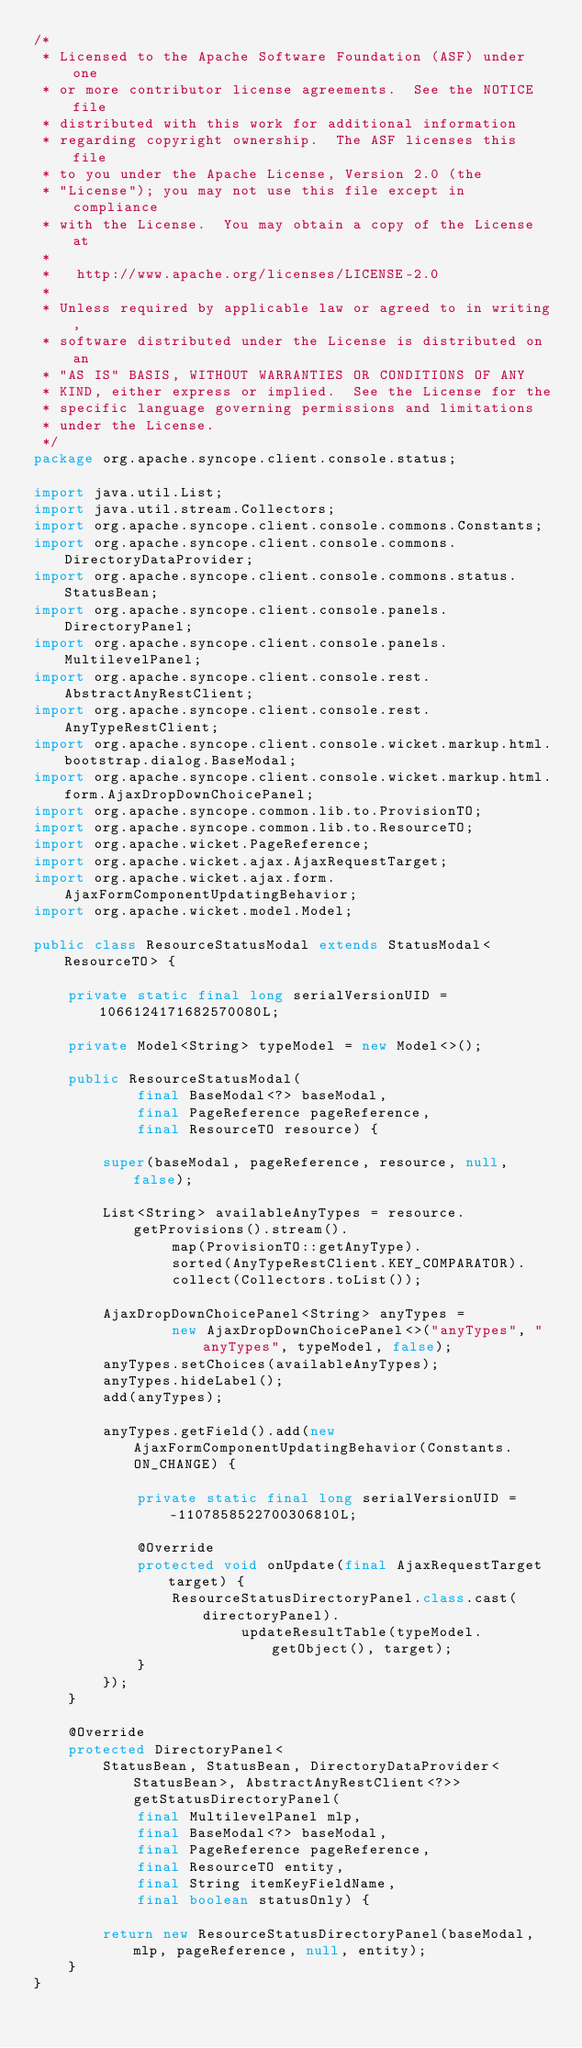<code> <loc_0><loc_0><loc_500><loc_500><_Java_>/*
 * Licensed to the Apache Software Foundation (ASF) under one
 * or more contributor license agreements.  See the NOTICE file
 * distributed with this work for additional information
 * regarding copyright ownership.  The ASF licenses this file
 * to you under the Apache License, Version 2.0 (the
 * "License"); you may not use this file except in compliance
 * with the License.  You may obtain a copy of the License at
 *
 *   http://www.apache.org/licenses/LICENSE-2.0
 *
 * Unless required by applicable law or agreed to in writing,
 * software distributed under the License is distributed on an
 * "AS IS" BASIS, WITHOUT WARRANTIES OR CONDITIONS OF ANY
 * KIND, either express or implied.  See the License for the
 * specific language governing permissions and limitations
 * under the License.
 */
package org.apache.syncope.client.console.status;

import java.util.List;
import java.util.stream.Collectors;
import org.apache.syncope.client.console.commons.Constants;
import org.apache.syncope.client.console.commons.DirectoryDataProvider;
import org.apache.syncope.client.console.commons.status.StatusBean;
import org.apache.syncope.client.console.panels.DirectoryPanel;
import org.apache.syncope.client.console.panels.MultilevelPanel;
import org.apache.syncope.client.console.rest.AbstractAnyRestClient;
import org.apache.syncope.client.console.rest.AnyTypeRestClient;
import org.apache.syncope.client.console.wicket.markup.html.bootstrap.dialog.BaseModal;
import org.apache.syncope.client.console.wicket.markup.html.form.AjaxDropDownChoicePanel;
import org.apache.syncope.common.lib.to.ProvisionTO;
import org.apache.syncope.common.lib.to.ResourceTO;
import org.apache.wicket.PageReference;
import org.apache.wicket.ajax.AjaxRequestTarget;
import org.apache.wicket.ajax.form.AjaxFormComponentUpdatingBehavior;
import org.apache.wicket.model.Model;

public class ResourceStatusModal extends StatusModal<ResourceTO> {

    private static final long serialVersionUID = 1066124171682570080L;

    private Model<String> typeModel = new Model<>();

    public ResourceStatusModal(
            final BaseModal<?> baseModal,
            final PageReference pageReference,
            final ResourceTO resource) {

        super(baseModal, pageReference, resource, null, false);

        List<String> availableAnyTypes = resource.getProvisions().stream().
                map(ProvisionTO::getAnyType).
                sorted(AnyTypeRestClient.KEY_COMPARATOR).
                collect(Collectors.toList());

        AjaxDropDownChoicePanel<String> anyTypes =
                new AjaxDropDownChoicePanel<>("anyTypes", "anyTypes", typeModel, false);
        anyTypes.setChoices(availableAnyTypes);
        anyTypes.hideLabel();
        add(anyTypes);

        anyTypes.getField().add(new AjaxFormComponentUpdatingBehavior(Constants.ON_CHANGE) {

            private static final long serialVersionUID = -1107858522700306810L;

            @Override
            protected void onUpdate(final AjaxRequestTarget target) {
                ResourceStatusDirectoryPanel.class.cast(directoryPanel).
                        updateResultTable(typeModel.getObject(), target);
            }
        });
    }

    @Override
    protected DirectoryPanel<
        StatusBean, StatusBean, DirectoryDataProvider<StatusBean>, AbstractAnyRestClient<?>> getStatusDirectoryPanel(
            final MultilevelPanel mlp,
            final BaseModal<?> baseModal,
            final PageReference pageReference,
            final ResourceTO entity,
            final String itemKeyFieldName,
            final boolean statusOnly) {

        return new ResourceStatusDirectoryPanel(baseModal, mlp, pageReference, null, entity);
    }
}
</code> 